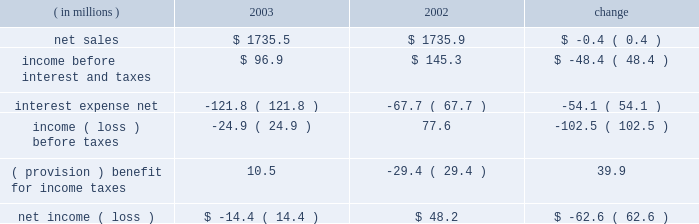Other expense , net , decreased $ 6.2 million , or 50.0% ( 50.0 % ) , for the year ended december 31 , 2004 compared to the year ended december 31 , 2003 .
The decrease was primarily due to a reduction in charges on disposal and transfer costs of fixed assets and facility closure costs of $ 3.3 million , reduced legal charges of $ 1.5 million , and a reduction in expenses of $ 1.4 million consisting of individually insignificant items .
Interest expense and income taxes interest expense decreased in 2004 by $ 92.2 million , or 75.7% ( 75.7 % ) , from 2003 .
This decrease included $ 73.3 million of expenses related to the company 2019s debt refinancing , which was completed in july 2003 .
The $ 73.3 million of expenses consisted of $ 55.9 million paid in premiums for the tender of the 95 20448% ( 20448 % ) senior subordinated notes , and a $ 17.4 million non-cash charge for the write-off of deferred financing fees related to the 95 20448% ( 20448 % ) notes and pca 2019s original revolving credit facility .
Excluding the $ 73.3 million charge , interest expense was $ 18.9 million lower than in 2003 as a result of lower interest rates attributable to the company 2019s july 2003 refinancing and lower debt levels .
Pca 2019s effective tax rate was 38.0% ( 38.0 % ) for the year ended december 31 , 2004 and 42.3% ( 42.3 % ) for the year ended december 31 , 2003 .
The higher tax rate in 2003 is due to stable permanent items over lower book income ( loss ) .
For both years 2004 and 2003 tax rates are higher than the federal statutory rate of 35.0% ( 35.0 % ) due to state income taxes .
Year ended december 31 , 2003 compared to year ended december 31 , 2002 the historical results of operations of pca for the years ended december 31 , 2003 and 2002 are set forth below : for the year ended december 31 , ( in millions ) 2003 2002 change .
Net sales net sales decreased by $ 0.4 million , or 0.0% ( 0.0 % ) , for the year ended december 31 , 2003 from the year ended december 31 , 2002 .
Net sales increased due to improved sales volumes compared to 2002 , however , this increase was entirely offset by lower sales prices .
Total corrugated products volume sold increased 2.1% ( 2.1 % ) to 28.1 billion square feet in 2003 compared to 27.5 billion square feet in 2002 .
On a comparable shipment-per-workday basis , corrugated products sales volume increased 1.7% ( 1.7 % ) in 2003 from 2002 .
Shipments-per-workday is calculated by dividing our total corrugated products volume during the year by the number of workdays within the year .
The lower percentage increase was due to the fact that 2003 had one more workday ( 252 days ) , those days not falling on a weekend or holiday , than 2002 ( 251 days ) .
Containerboard sales volume to external domestic and export customers decreased 6.7% ( 6.7 % ) to 445000 tons for the year ended december 31 , 2003 from 477000 tons in the comparable period of 2002 .
Income before interest and taxes income before interest and taxes decreased by $ 48.4 million , or 33.3% ( 33.3 % ) , for the year ended december 31 , 2003 compared to 2002 .
Included in income before interest and taxes for the twelve months .
What was the operating margin for 2003? 
Computations: (96.9 / 1735.5)
Answer: 0.05583. 